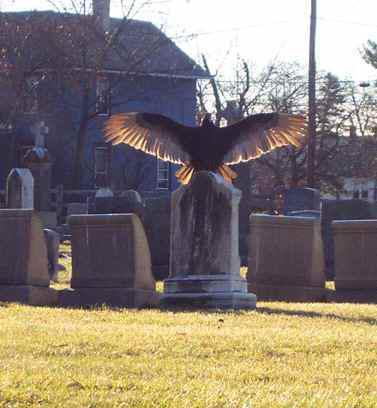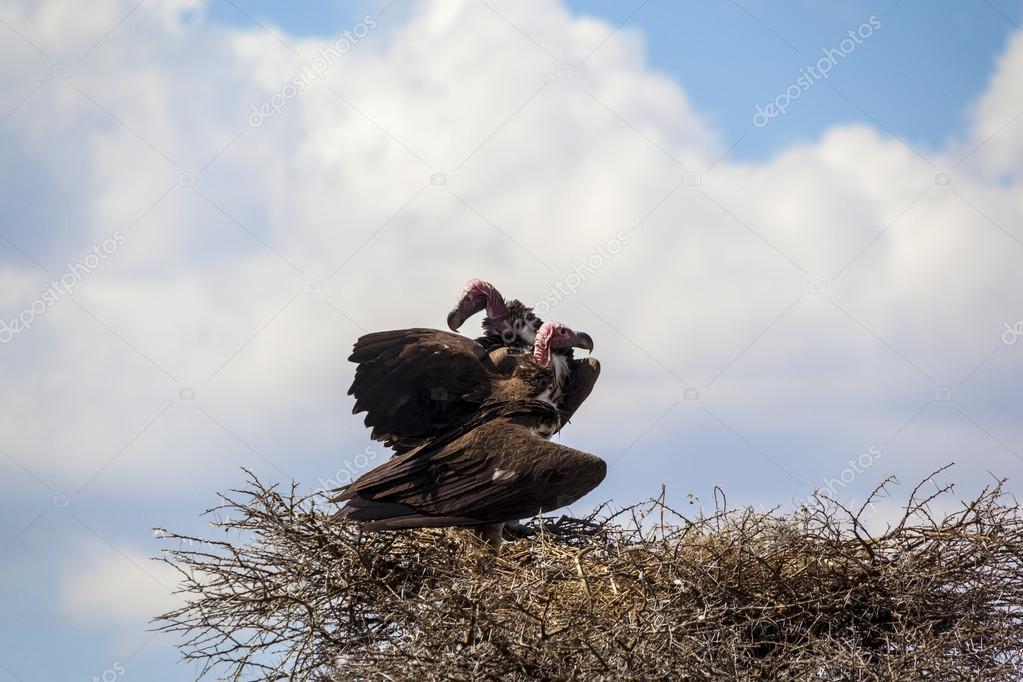The first image is the image on the left, the second image is the image on the right. Examine the images to the left and right. Is the description "An image contains just one bird, perched with outspread wings on an object that is not a tree branch." accurate? Answer yes or no. Yes. The first image is the image on the left, the second image is the image on the right. For the images displayed, is the sentence "The bird in the image on the left has its wings spread wide." factually correct? Answer yes or no. Yes. 